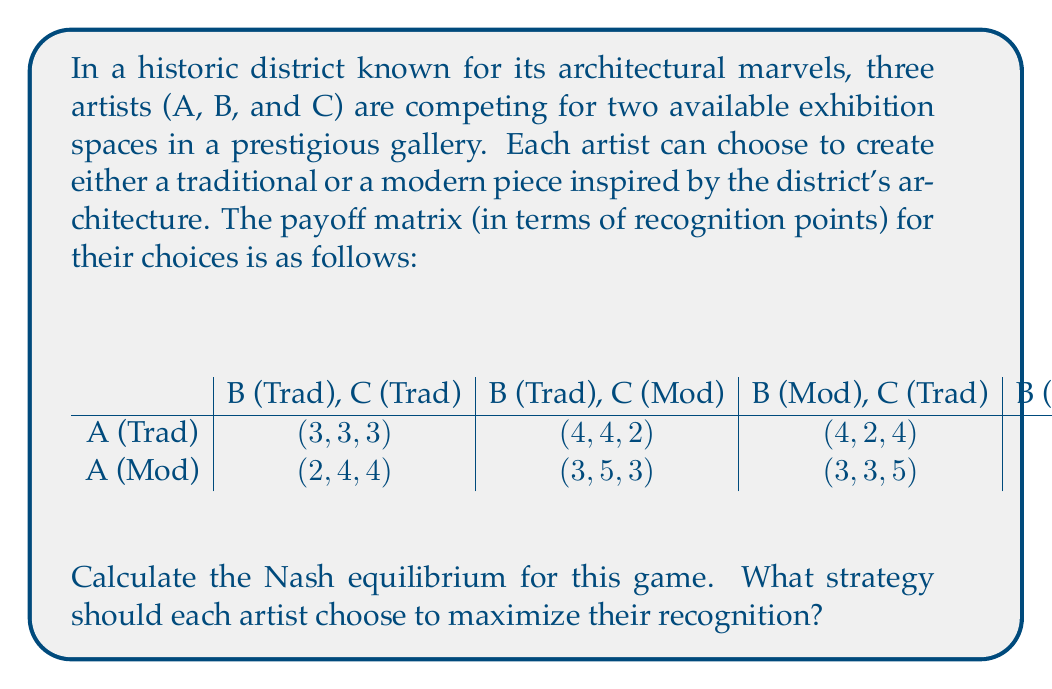Can you answer this question? To find the Nash equilibrium, we need to analyze each artist's best response to the other artists' strategies. Let's approach this step-by-step:

1. First, let's consider Artist A's choices:
   - If B and C both choose Traditional: A's best response is Traditional (3 > 2)
   - If B chooses Traditional and C chooses Modern: A's best response is Traditional (4 > 3)
   - If B chooses Modern and C chooses Traditional: A's best response is Traditional (4 > 3)
   - If B and C both choose Modern: A's best response is Modern (4 > 3)

2. Now, let's consider Artist B's choices:
   - If A chooses Traditional and C chooses Traditional: B's best response is Traditional (3 > 2)
   - If A chooses Traditional and C chooses Modern: B's best response is Traditional (4 > 3)
   - If A chooses Modern and C chooses Traditional: B's best response is Traditional (4 > 3)
   - If A chooses Modern and C chooses Modern: B's best response is Modern (4 > 3)

3. Finally, let's consider Artist C's choices:
   - If A chooses Traditional and B chooses Traditional: C's best response is Traditional (3 > 2)
   - If A chooses Traditional and B chooses Modern: C's best response is Traditional (4 > 3)
   - If A chooses Modern and B chooses Traditional: C's best response is Traditional (4 > 3)
   - If A chooses Modern and B chooses Modern: C's best response is Modern (4 > 3)

4. Analyzing these best responses, we can see that there are two pure strategy Nash equilibria:
   a. (Traditional, Traditional, Traditional) with payoffs (3, 3, 3)
   b. (Modern, Modern, Modern) with payoffs (4, 4, 4)

5. The (Modern, Modern, Modern) equilibrium Pareto dominates the (Traditional, Traditional, Traditional) equilibrium, as it provides higher payoffs for all artists.

Therefore, the Nash equilibrium that maximizes recognition for all artists is when they all choose to create modern pieces inspired by the district's architecture.
Answer: The Nash equilibrium that maximizes recognition for all artists is (Modern, Modern, Modern) with payoffs (4, 4, 4). Each artist should choose to create a modern piece inspired by the district's architecture. 